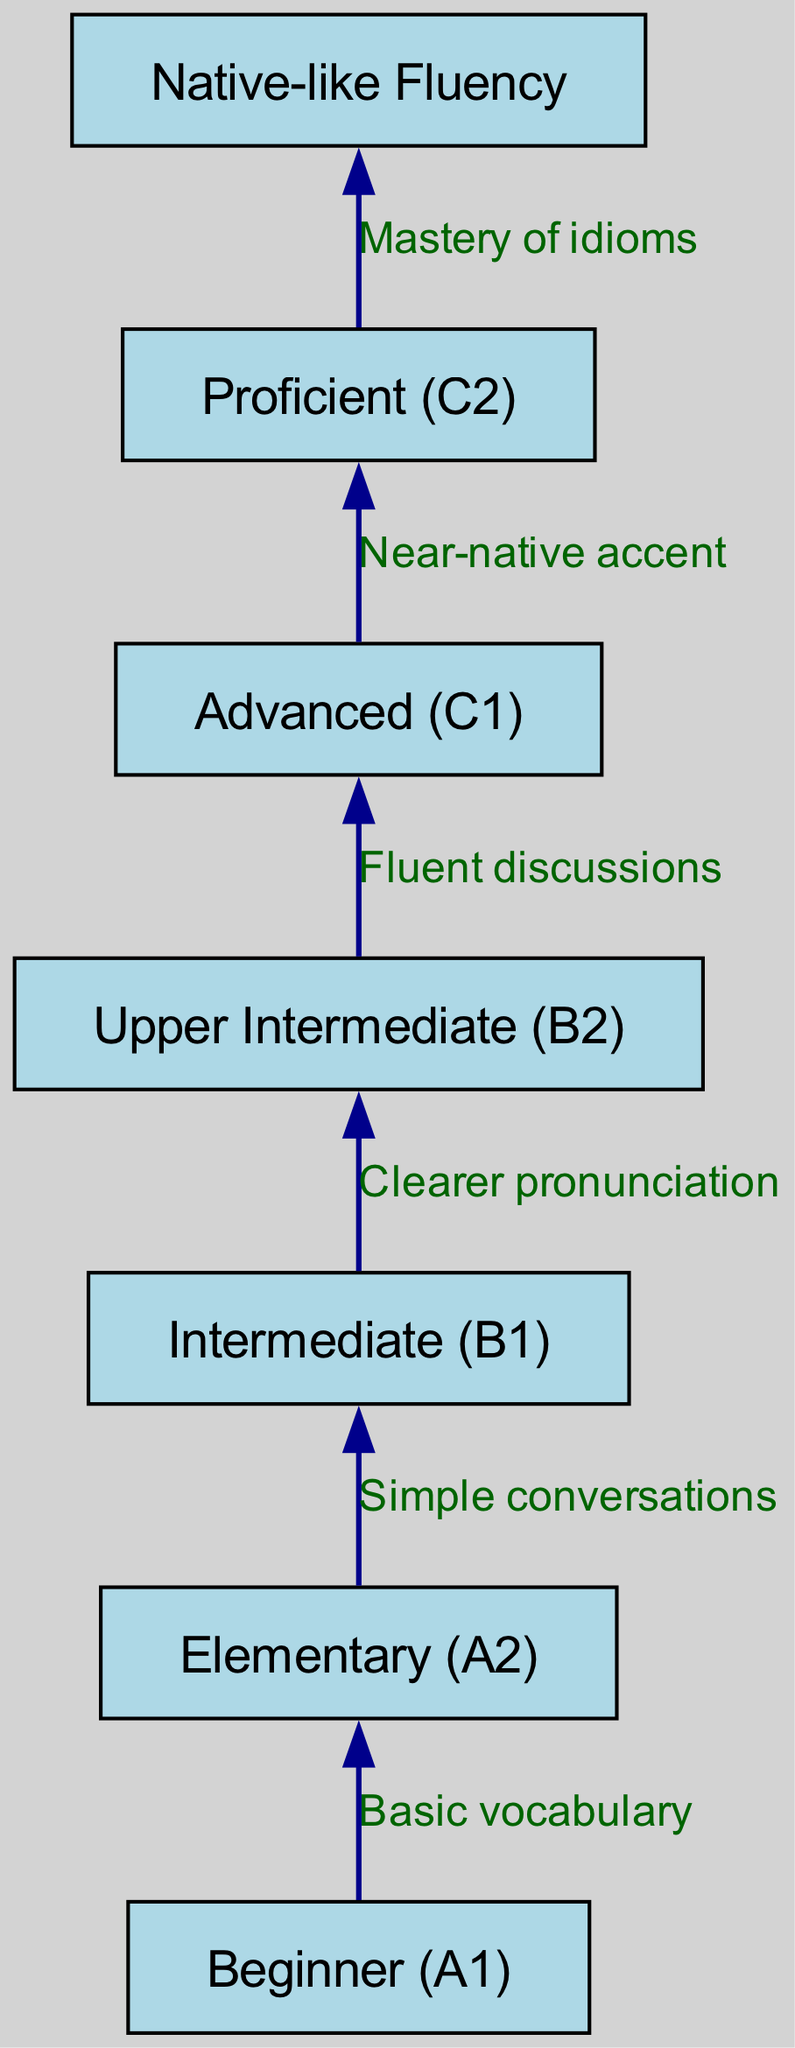What is the highest proficiency level indicated in the diagram? The highest proficiency level is located at the top of the flow chart, which is labeled as "Native-like Fluency."
Answer: Native-like Fluency What skill does a learner develop when progressing from Intermediate (B1) to Upper Intermediate (B2)? This transition involves developing "Clearer pronunciation," which is specifically mentioned as the skill gained in this step.
Answer: Clearer pronunciation How many total proficiency levels are shown in the diagram? By counting the number of nodes listed in the diagram, there are seven levels of proficiency represented.
Answer: 7 What is the relationship between Elementary (A2) and Intermediate (B1)? The flow chart shows a directional edge from Elementary (A2) to Intermediate (B1), indicating that the relationship involves "Simple conversations" as the skill developed during this transition.
Answer: Simple conversations What must a learner achieve after reaching Proficient (C2) to attain Native-like Fluency? The flow from Proficient (C2) to Native-like Fluency indicates that mastering "idioms" is necessary for this transition, illustrating an advanced understanding of language nuances.
Answer: Mastery of idioms What proficiency level comes before Advanced (C1)? The diagram displays a clear flow leading into Advanced (C1) from Upper Intermediate (B2), establishing the hierarchy of levels.
Answer: Upper Intermediate (B2) Which proficiency level is described with the phrase "Near-native accent"? The phrase "Near-native accent" is specifically associated with the Advanced (C1) proficiency level, indicating the accuracy of pronunciation and intonation achieved at this stage.
Answer: Advanced (C1) 